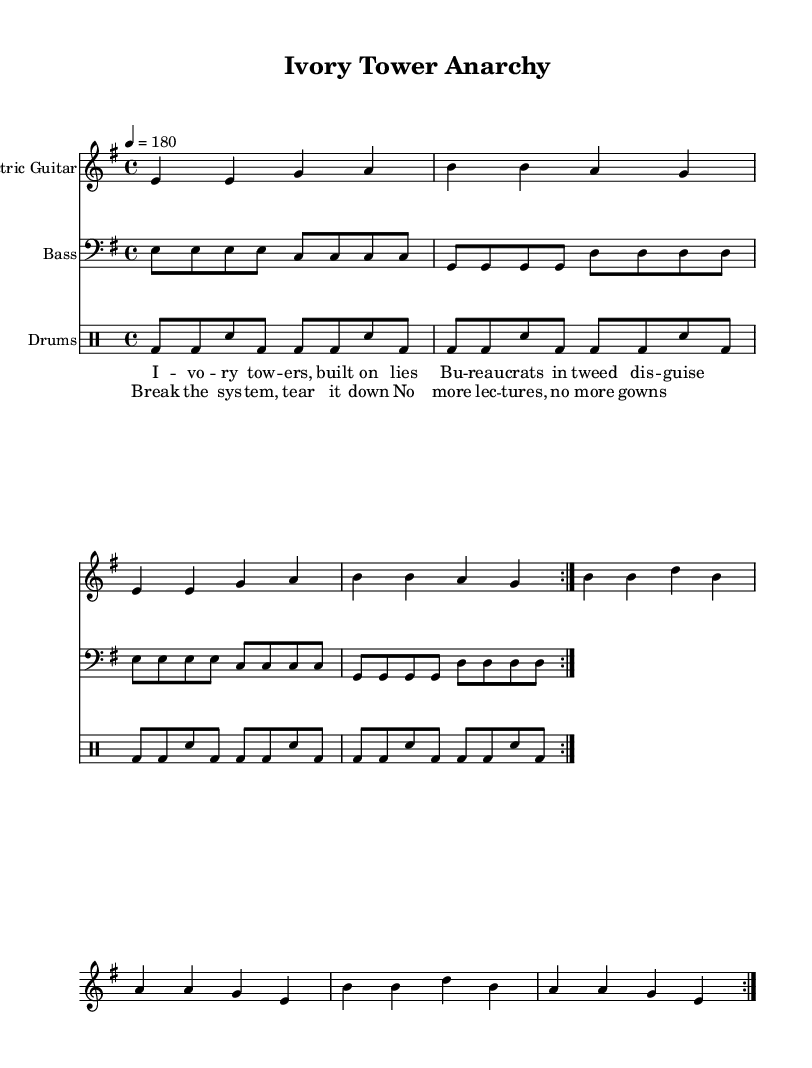What is the key signature of this music? The key signature is found at the beginning of the music sheet, where a clef and key signature are indicated. Here, it shows one sharp, which corresponds to E minor.
Answer: E minor What is the time signature of this music? The time signature is a numerals indication at the beginning of the score. In this case, it shows 4/4, meaning there are four beats per measure, and each quarter note receives one beat.
Answer: 4/4 What is the tempo marking of this music? The tempo marking is indicated near the beginning of the score and is expressed in beats per minute. Here it shows a tempo of 180, meaning the music should be played at a fast pace.
Answer: 180 How many times is the verse section repeated? The verse section is indicated with a repeat sign, shown in the measure markings. The repeat sign appears once, indicating that the verse is played two times.
Answer: 2 What instrument plays the main rhythm in this piece? The main rhythmic aspect of Punk rock is often driven by the electric guitar, which plays the primary chords and structure in this score.
Answer: Electric Guitar What is the lyrical theme of the chorus? The lyrics in the chorus center around rebellion against academic norms and systems, clearly expressing a desire to dismantle traditional structures in academia.
Answer: A desire to dismantle traditional structures 